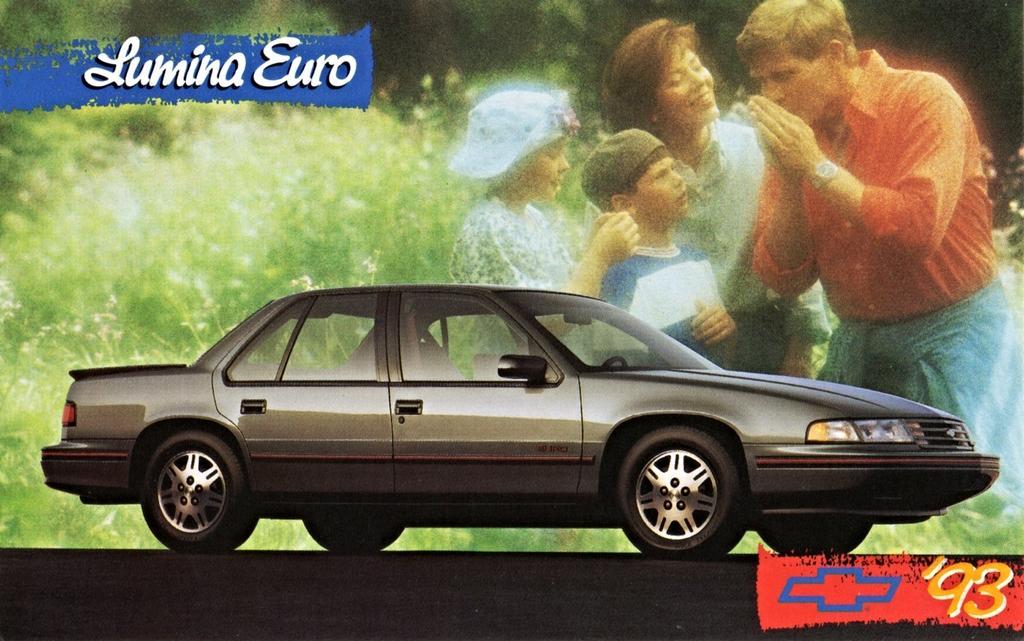Describe this image in one or two sentences. In this picture we can see a car with a projector display behind it. 